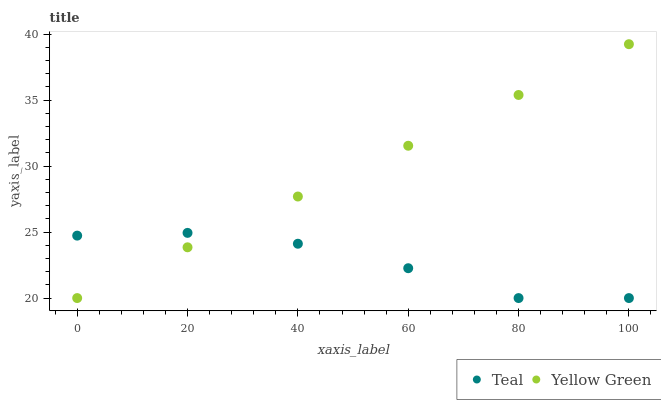Does Teal have the minimum area under the curve?
Answer yes or no. Yes. Does Yellow Green have the maximum area under the curve?
Answer yes or no. Yes. Does Teal have the maximum area under the curve?
Answer yes or no. No. Is Yellow Green the smoothest?
Answer yes or no. Yes. Is Teal the roughest?
Answer yes or no. Yes. Is Teal the smoothest?
Answer yes or no. No. Does Yellow Green have the lowest value?
Answer yes or no. Yes. Does Yellow Green have the highest value?
Answer yes or no. Yes. Does Teal have the highest value?
Answer yes or no. No. Does Teal intersect Yellow Green?
Answer yes or no. Yes. Is Teal less than Yellow Green?
Answer yes or no. No. Is Teal greater than Yellow Green?
Answer yes or no. No. 